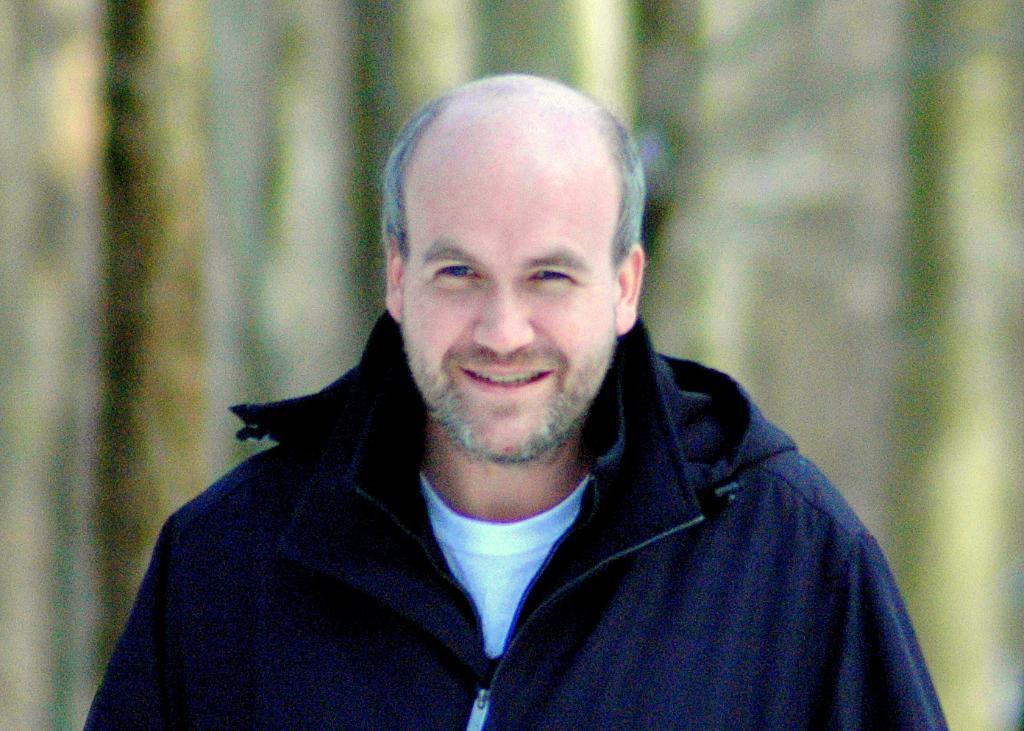Describe this image in one or two sentences. In this image there is a man in the middle who is wearing the blue colour jacket. 